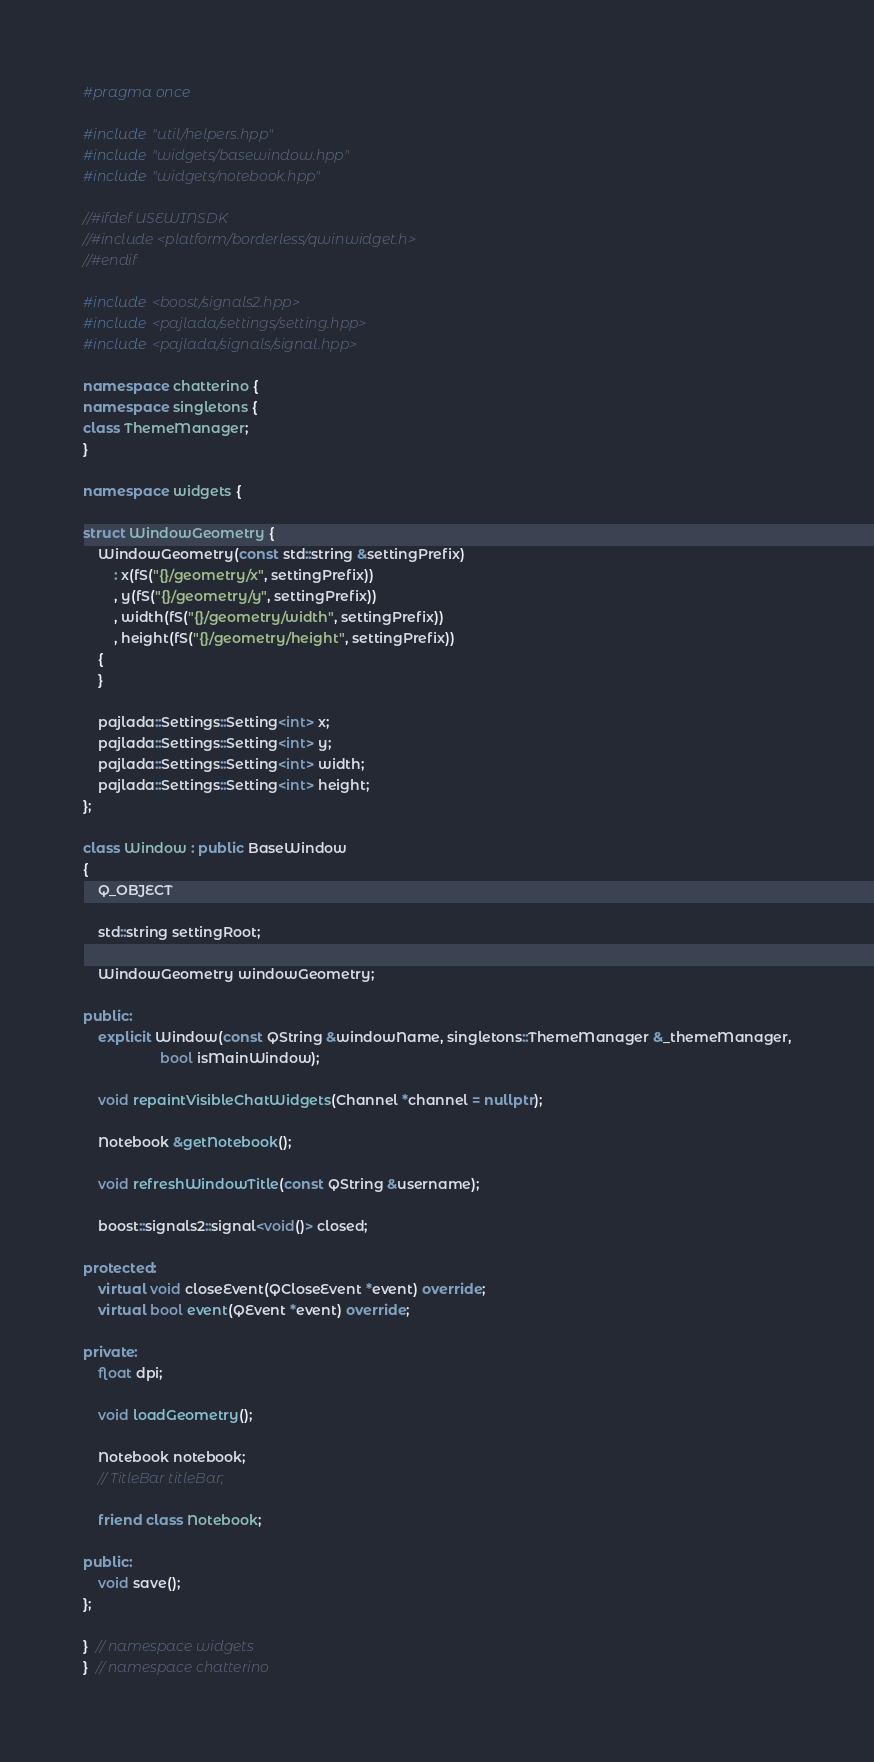Convert code to text. <code><loc_0><loc_0><loc_500><loc_500><_C++_>#pragma once

#include "util/helpers.hpp"
#include "widgets/basewindow.hpp"
#include "widgets/notebook.hpp"

//#ifdef USEWINSDK
//#include <platform/borderless/qwinwidget.h>
//#endif

#include <boost/signals2.hpp>
#include <pajlada/settings/setting.hpp>
#include <pajlada/signals/signal.hpp>

namespace chatterino {
namespace singletons {
class ThemeManager;
}

namespace widgets {

struct WindowGeometry {
    WindowGeometry(const std::string &settingPrefix)
        : x(fS("{}/geometry/x", settingPrefix))
        , y(fS("{}/geometry/y", settingPrefix))
        , width(fS("{}/geometry/width", settingPrefix))
        , height(fS("{}/geometry/height", settingPrefix))
    {
    }

    pajlada::Settings::Setting<int> x;
    pajlada::Settings::Setting<int> y;
    pajlada::Settings::Setting<int> width;
    pajlada::Settings::Setting<int> height;
};

class Window : public BaseWindow
{
    Q_OBJECT

    std::string settingRoot;

    WindowGeometry windowGeometry;

public:
    explicit Window(const QString &windowName, singletons::ThemeManager &_themeManager,
                    bool isMainWindow);

    void repaintVisibleChatWidgets(Channel *channel = nullptr);

    Notebook &getNotebook();

    void refreshWindowTitle(const QString &username);

    boost::signals2::signal<void()> closed;

protected:
    virtual void closeEvent(QCloseEvent *event) override;
    virtual bool event(QEvent *event) override;

private:
    float dpi;

    void loadGeometry();

    Notebook notebook;
    // TitleBar titleBar;

    friend class Notebook;

public:
    void save();
};

}  // namespace widgets
}  // namespace chatterino
</code> 